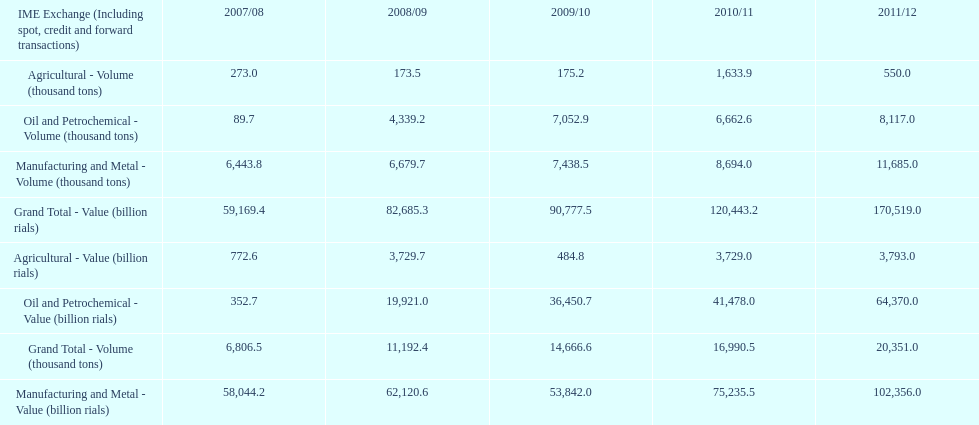Which year had the largest agricultural volume? 2010/11. 